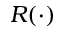Convert formula to latex. <formula><loc_0><loc_0><loc_500><loc_500>R ( \cdot )</formula> 